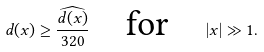<formula> <loc_0><loc_0><loc_500><loc_500>d ( x ) \geq \frac { \widehat { d ( x ) } } { 3 2 0 } \quad \text {for} \quad | x | \gg 1 .</formula> 